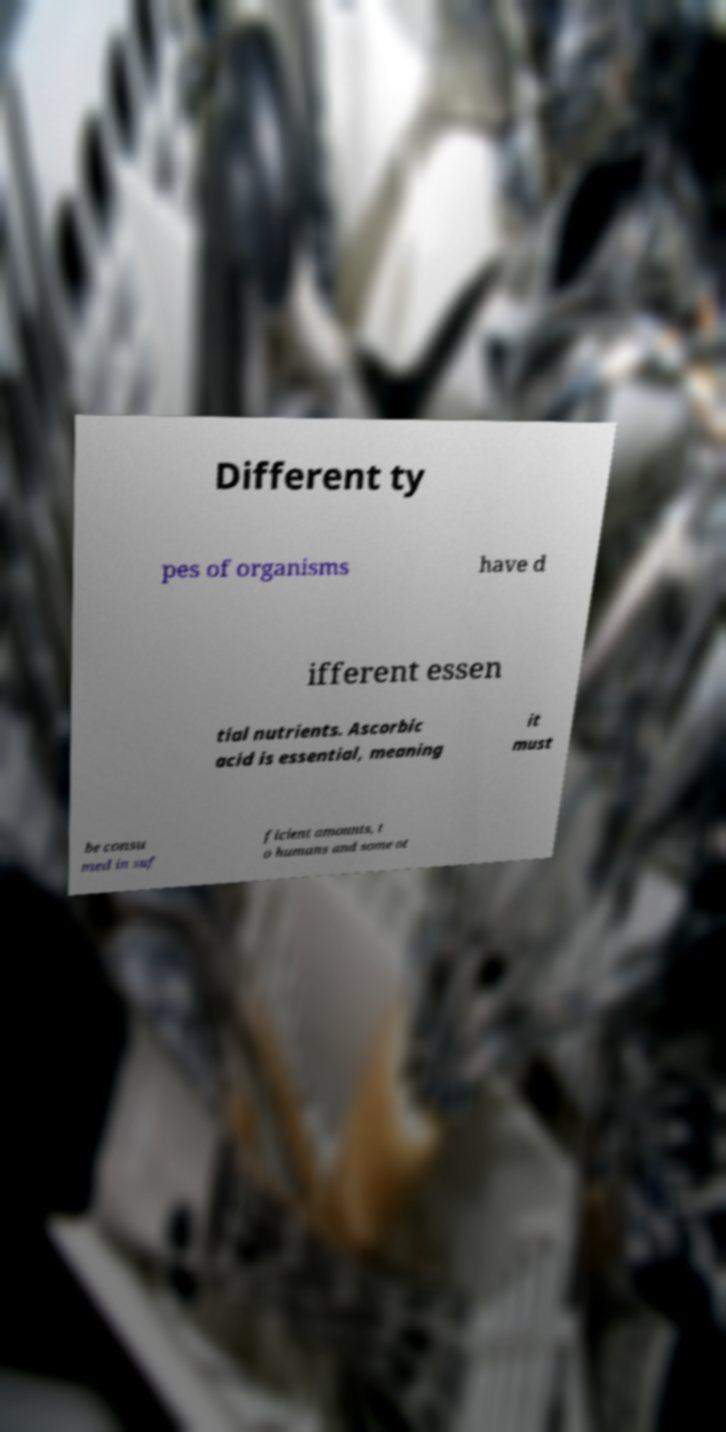There's text embedded in this image that I need extracted. Can you transcribe it verbatim? Different ty pes of organisms have d ifferent essen tial nutrients. Ascorbic acid is essential, meaning it must be consu med in suf ficient amounts, t o humans and some ot 